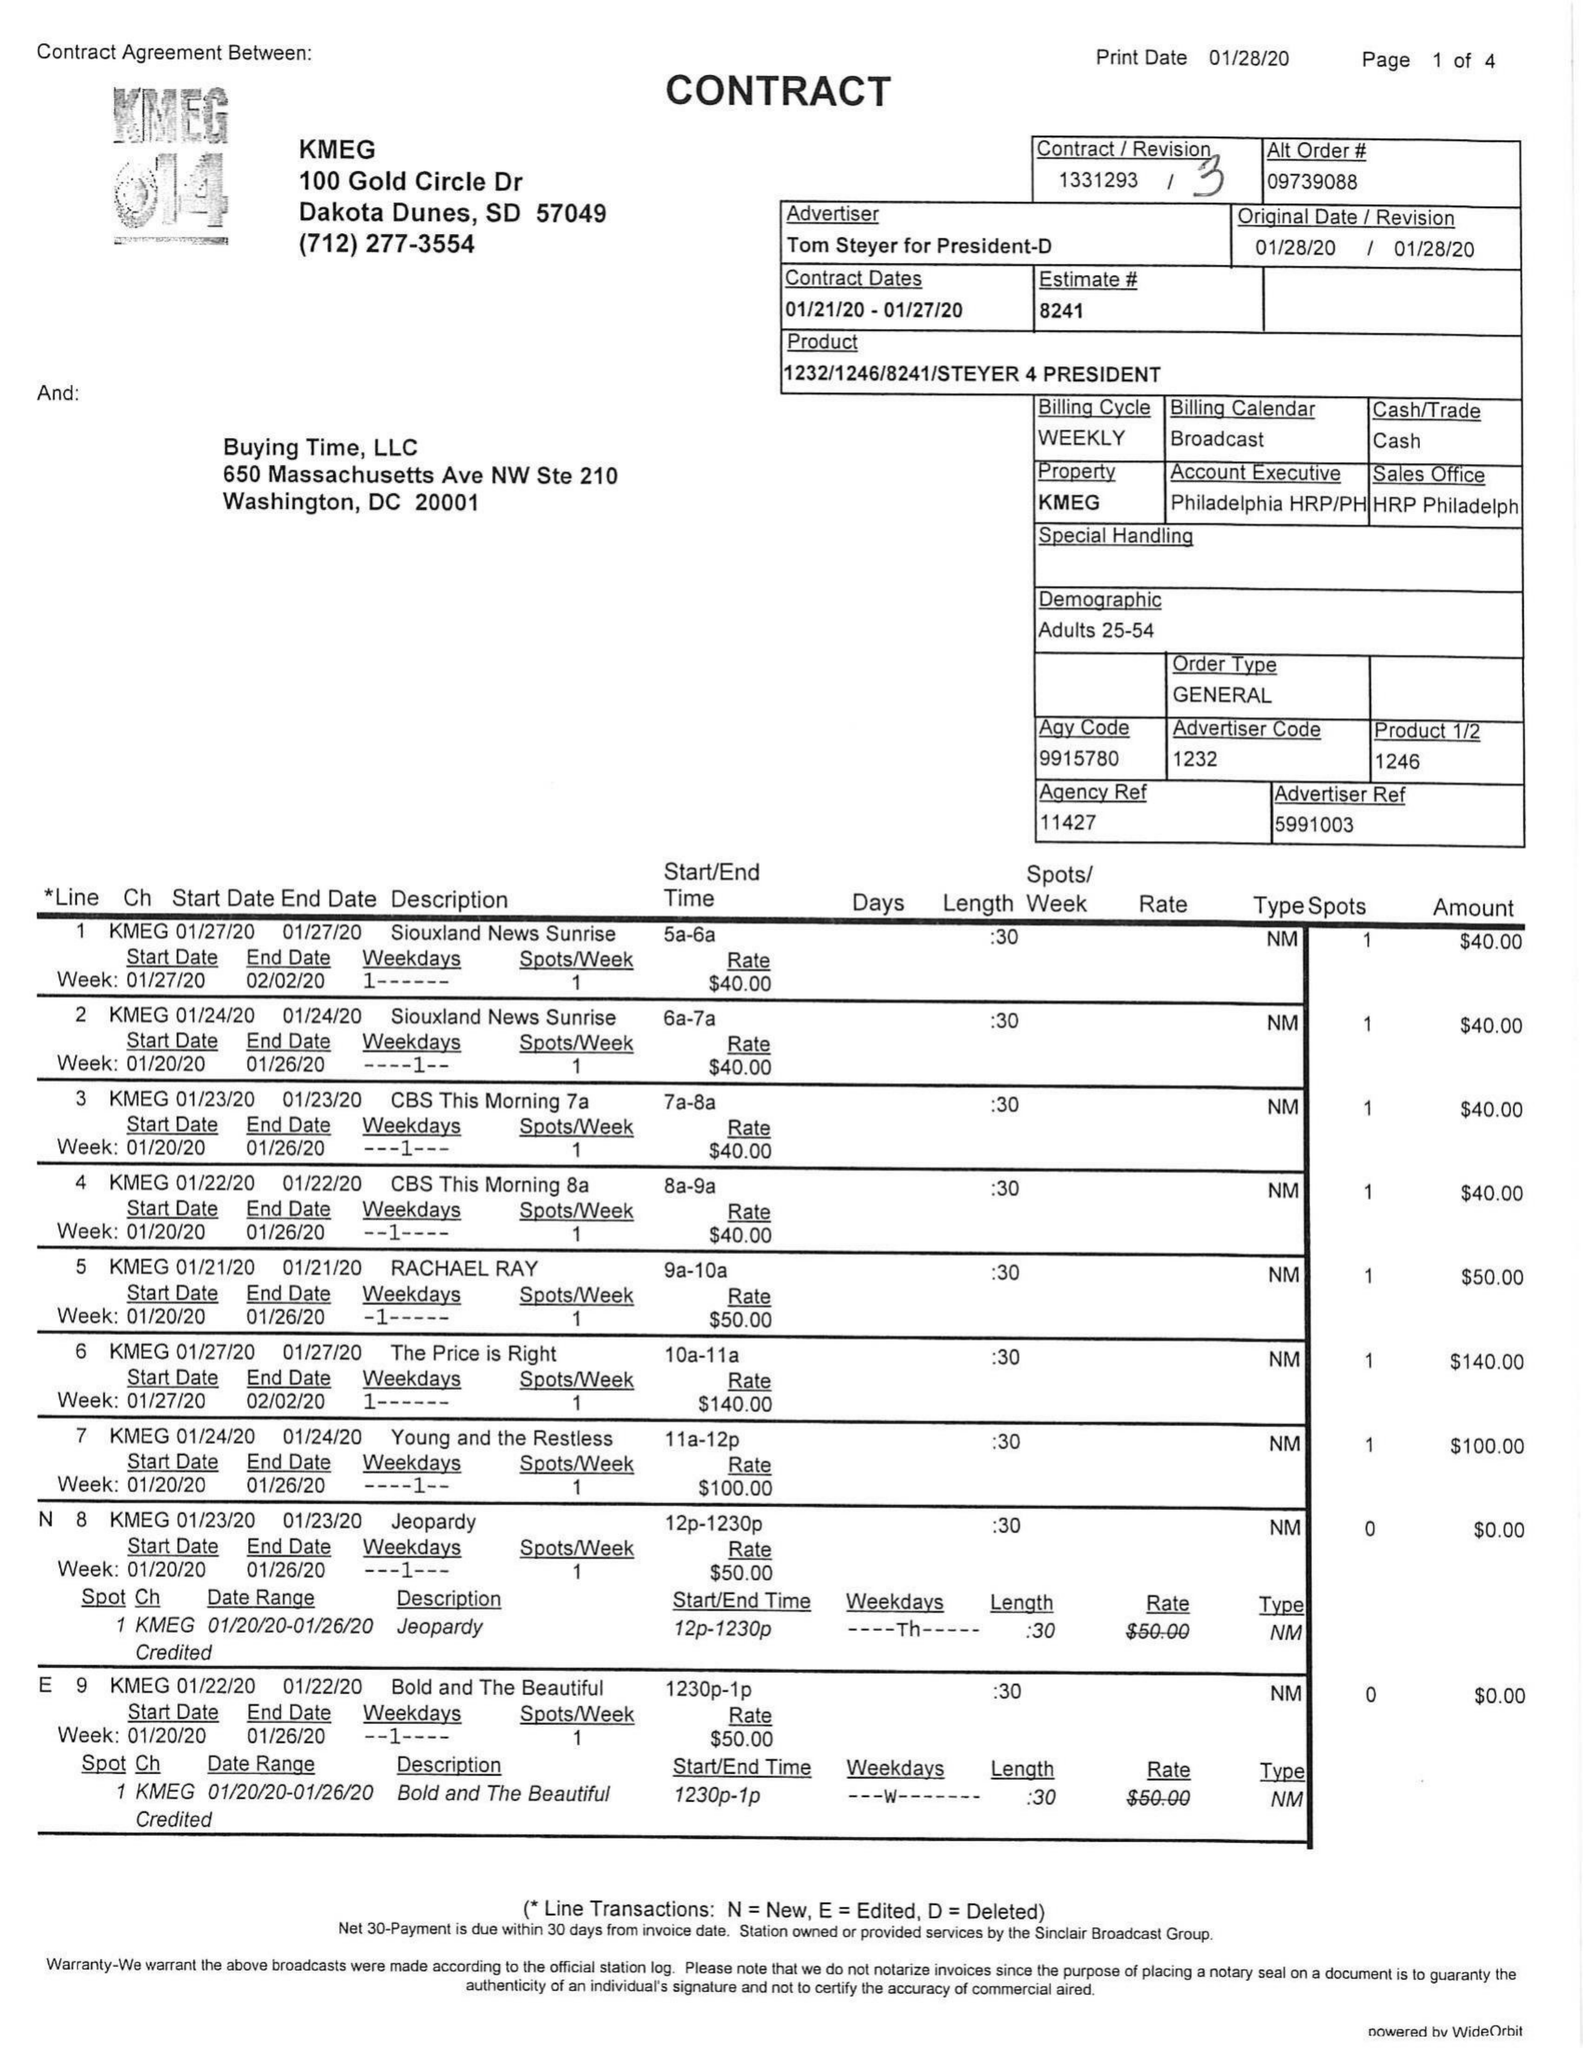What is the value for the flight_from?
Answer the question using a single word or phrase. 01/21/20 